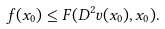Convert formula to latex. <formula><loc_0><loc_0><loc_500><loc_500>f ( x _ { 0 } ) \leq F ( D ^ { 2 } v ( x _ { 0 } ) , x _ { 0 } ) .</formula> 